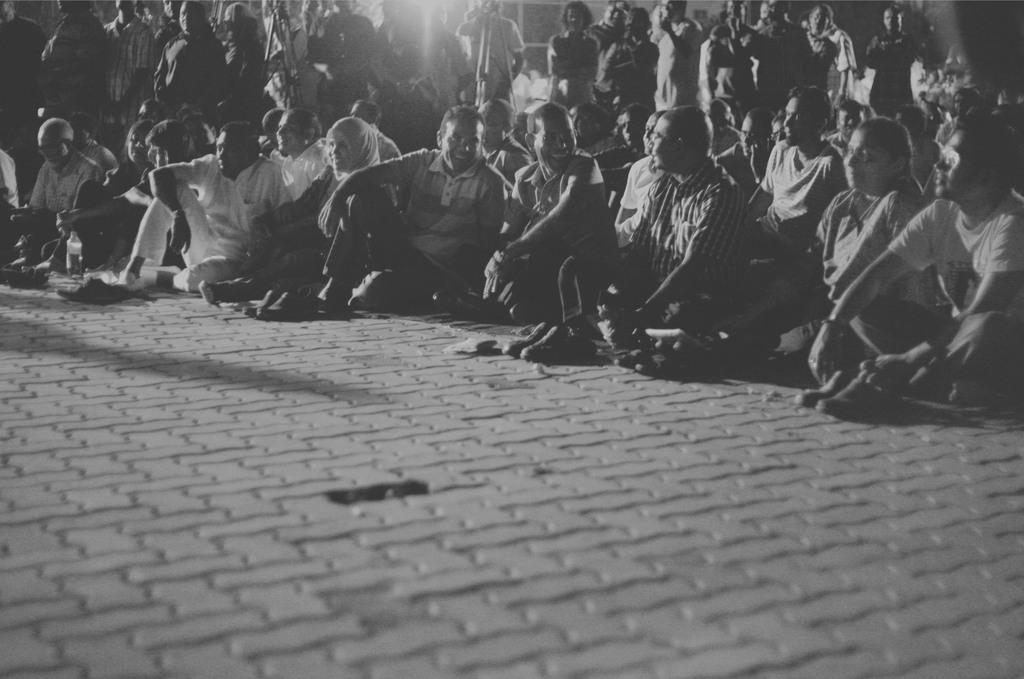Please provide a concise description of this image. In this image I can see the black and white picture in which I can see the ground, number of persons sitting on the ground, a bottle and number of persons are standing on the ground. 